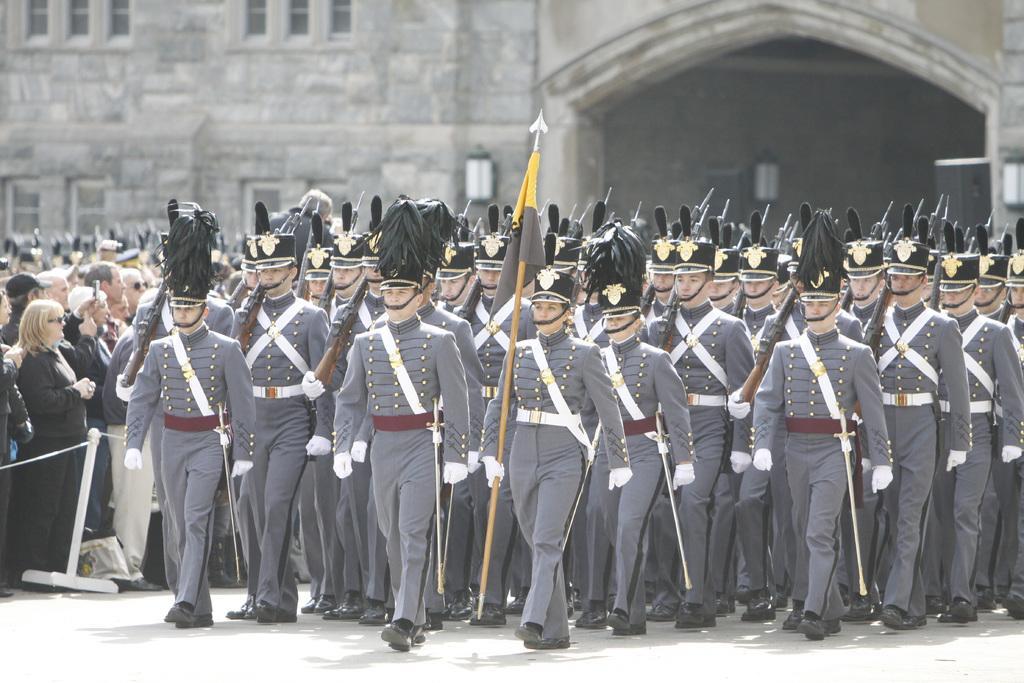Please provide a concise description of this image. Here in this picture we can see a group of men walking on the ground with same kind of uniform and cap on them and the person in the front is holding a spear in his hand and beside them we can see number of other people standing and watching them and we can also see an old building with number of windows present over there. 